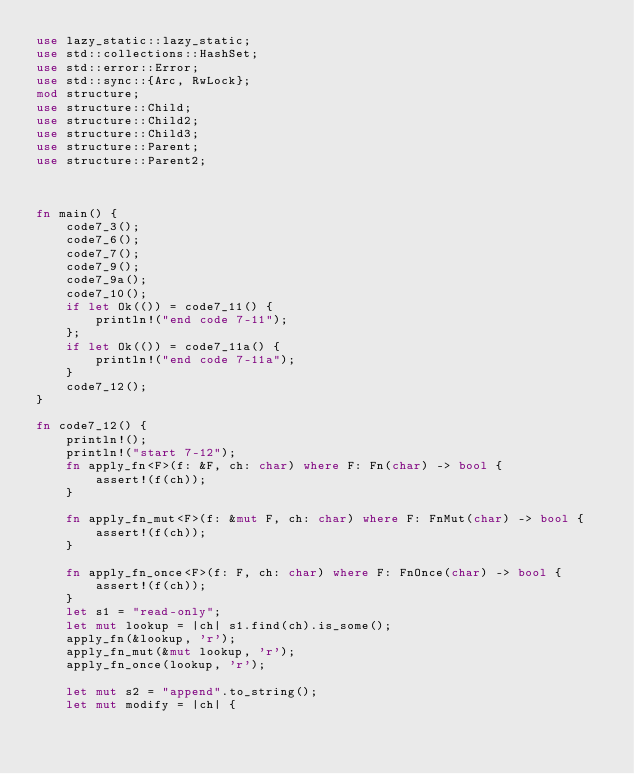<code> <loc_0><loc_0><loc_500><loc_500><_Rust_>use lazy_static::lazy_static;
use std::collections::HashSet;
use std::error::Error;
use std::sync::{Arc, RwLock};
mod structure;
use structure::Child;
use structure::Child2;
use structure::Child3;
use structure::Parent;
use structure::Parent2;



fn main() {
    code7_3();
    code7_6();
    code7_7();
    code7_9();
    code7_9a();
    code7_10();
    if let Ok(()) = code7_11() {
        println!("end code 7-11");
    };
    if let Ok(()) = code7_11a() {
        println!("end code 7-11a");
    }
    code7_12();
}

fn code7_12() {
    println!();
    println!("start 7-12");
    fn apply_fn<F>(f: &F, ch: char) where F: Fn(char) -> bool {
        assert!(f(ch));
    }

    fn apply_fn_mut<F>(f: &mut F, ch: char) where F: FnMut(char) -> bool {
        assert!(f(ch));
    }

    fn apply_fn_once<F>(f: F, ch: char) where F: FnOnce(char) -> bool {
        assert!(f(ch));
    }
    let s1 = "read-only";
    let mut lookup = |ch| s1.find(ch).is_some();
    apply_fn(&lookup, 'r');
    apply_fn_mut(&mut lookup, 'r');
    apply_fn_once(lookup, 'r');

    let mut s2 = "append".to_string();
    let mut modify = |ch| {</code> 